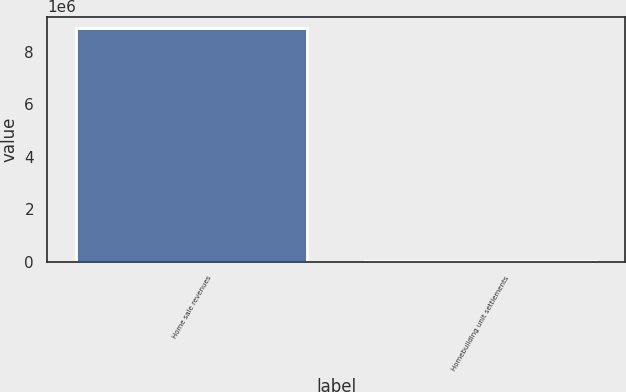Convert chart. <chart><loc_0><loc_0><loc_500><loc_500><bar_chart><fcel>Home sale revenues<fcel>Homebuilding unit settlements<nl><fcel>8.88151e+06<fcel>27540<nl></chart> 